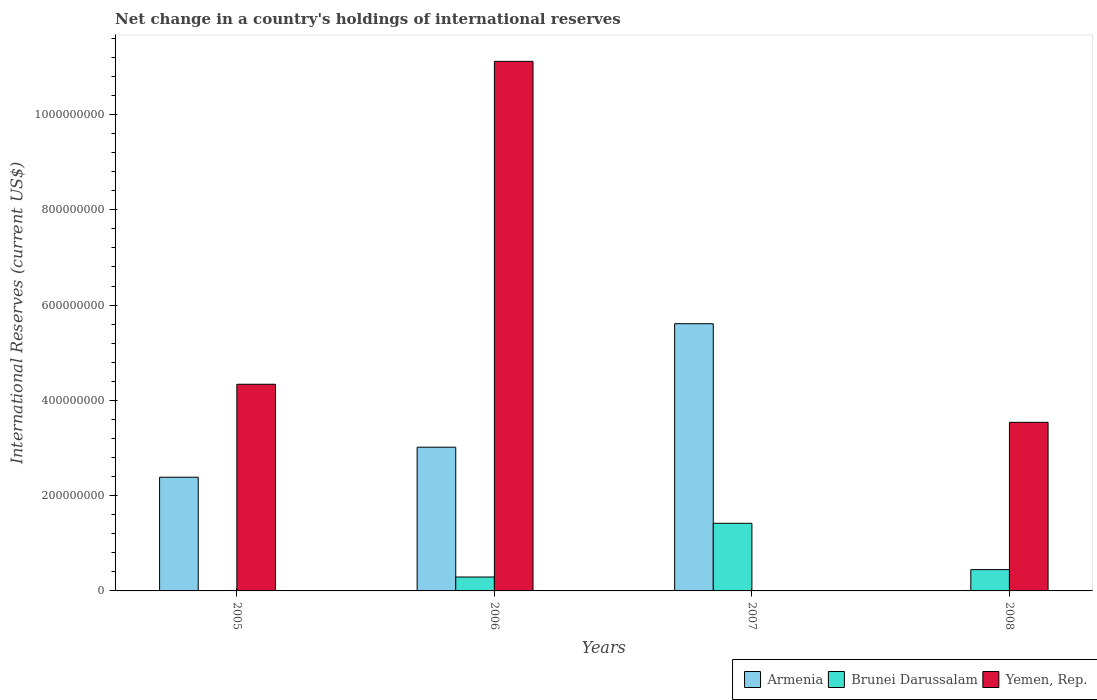How many different coloured bars are there?
Your answer should be very brief. 3. How many groups of bars are there?
Provide a succinct answer. 4. Are the number of bars per tick equal to the number of legend labels?
Keep it short and to the point. No. How many bars are there on the 2nd tick from the right?
Your answer should be compact. 2. What is the label of the 1st group of bars from the left?
Your response must be concise. 2005. In how many cases, is the number of bars for a given year not equal to the number of legend labels?
Ensure brevity in your answer.  3. Across all years, what is the maximum international reserves in Brunei Darussalam?
Provide a succinct answer. 1.42e+08. What is the total international reserves in Yemen, Rep. in the graph?
Keep it short and to the point. 1.90e+09. What is the difference between the international reserves in Armenia in 2005 and that in 2007?
Offer a very short reply. -3.22e+08. What is the difference between the international reserves in Brunei Darussalam in 2008 and the international reserves in Armenia in 2005?
Offer a very short reply. -1.94e+08. What is the average international reserves in Brunei Darussalam per year?
Your answer should be very brief. 5.40e+07. In the year 2006, what is the difference between the international reserves in Armenia and international reserves in Brunei Darussalam?
Provide a short and direct response. 2.72e+08. In how many years, is the international reserves in Armenia greater than 1000000000 US$?
Offer a terse response. 0. What is the ratio of the international reserves in Brunei Darussalam in 2007 to that in 2008?
Keep it short and to the point. 3.17. Is the international reserves in Armenia in 2005 less than that in 2007?
Your answer should be compact. Yes. Is the difference between the international reserves in Armenia in 2006 and 2007 greater than the difference between the international reserves in Brunei Darussalam in 2006 and 2007?
Ensure brevity in your answer.  No. What is the difference between the highest and the second highest international reserves in Brunei Darussalam?
Ensure brevity in your answer.  9.72e+07. What is the difference between the highest and the lowest international reserves in Yemen, Rep.?
Your response must be concise. 1.11e+09. In how many years, is the international reserves in Brunei Darussalam greater than the average international reserves in Brunei Darussalam taken over all years?
Make the answer very short. 1. Is the sum of the international reserves in Armenia in 2005 and 2006 greater than the maximum international reserves in Brunei Darussalam across all years?
Your answer should be compact. Yes. Is it the case that in every year, the sum of the international reserves in Armenia and international reserves in Yemen, Rep. is greater than the international reserves in Brunei Darussalam?
Offer a terse response. Yes. How many bars are there?
Provide a succinct answer. 9. How many years are there in the graph?
Your answer should be compact. 4. Are the values on the major ticks of Y-axis written in scientific E-notation?
Offer a very short reply. No. Does the graph contain any zero values?
Offer a terse response. Yes. Where does the legend appear in the graph?
Keep it short and to the point. Bottom right. What is the title of the graph?
Give a very brief answer. Net change in a country's holdings of international reserves. Does "Other small states" appear as one of the legend labels in the graph?
Your answer should be compact. No. What is the label or title of the Y-axis?
Your answer should be compact. International Reserves (current US$). What is the International Reserves (current US$) in Armenia in 2005?
Provide a succinct answer. 2.39e+08. What is the International Reserves (current US$) in Yemen, Rep. in 2005?
Your answer should be very brief. 4.34e+08. What is the International Reserves (current US$) of Armenia in 2006?
Your response must be concise. 3.02e+08. What is the International Reserves (current US$) of Brunei Darussalam in 2006?
Keep it short and to the point. 2.92e+07. What is the International Reserves (current US$) of Yemen, Rep. in 2006?
Provide a succinct answer. 1.11e+09. What is the International Reserves (current US$) of Armenia in 2007?
Offer a very short reply. 5.61e+08. What is the International Reserves (current US$) of Brunei Darussalam in 2007?
Give a very brief answer. 1.42e+08. What is the International Reserves (current US$) of Yemen, Rep. in 2007?
Give a very brief answer. 0. What is the International Reserves (current US$) in Armenia in 2008?
Provide a short and direct response. 0. What is the International Reserves (current US$) in Brunei Darussalam in 2008?
Offer a terse response. 4.47e+07. What is the International Reserves (current US$) in Yemen, Rep. in 2008?
Your answer should be compact. 3.54e+08. Across all years, what is the maximum International Reserves (current US$) in Armenia?
Ensure brevity in your answer.  5.61e+08. Across all years, what is the maximum International Reserves (current US$) of Brunei Darussalam?
Provide a short and direct response. 1.42e+08. Across all years, what is the maximum International Reserves (current US$) in Yemen, Rep.?
Your answer should be very brief. 1.11e+09. Across all years, what is the minimum International Reserves (current US$) in Armenia?
Offer a very short reply. 0. Across all years, what is the minimum International Reserves (current US$) in Brunei Darussalam?
Provide a succinct answer. 0. What is the total International Reserves (current US$) of Armenia in the graph?
Provide a succinct answer. 1.10e+09. What is the total International Reserves (current US$) of Brunei Darussalam in the graph?
Your answer should be very brief. 2.16e+08. What is the total International Reserves (current US$) in Yemen, Rep. in the graph?
Make the answer very short. 1.90e+09. What is the difference between the International Reserves (current US$) of Armenia in 2005 and that in 2006?
Offer a very short reply. -6.30e+07. What is the difference between the International Reserves (current US$) in Yemen, Rep. in 2005 and that in 2006?
Ensure brevity in your answer.  -6.78e+08. What is the difference between the International Reserves (current US$) in Armenia in 2005 and that in 2007?
Give a very brief answer. -3.22e+08. What is the difference between the International Reserves (current US$) of Yemen, Rep. in 2005 and that in 2008?
Your answer should be very brief. 7.99e+07. What is the difference between the International Reserves (current US$) of Armenia in 2006 and that in 2007?
Offer a very short reply. -2.59e+08. What is the difference between the International Reserves (current US$) of Brunei Darussalam in 2006 and that in 2007?
Your response must be concise. -1.13e+08. What is the difference between the International Reserves (current US$) in Brunei Darussalam in 2006 and that in 2008?
Your answer should be very brief. -1.55e+07. What is the difference between the International Reserves (current US$) in Yemen, Rep. in 2006 and that in 2008?
Offer a very short reply. 7.58e+08. What is the difference between the International Reserves (current US$) in Brunei Darussalam in 2007 and that in 2008?
Offer a very short reply. 9.72e+07. What is the difference between the International Reserves (current US$) in Armenia in 2005 and the International Reserves (current US$) in Brunei Darussalam in 2006?
Give a very brief answer. 2.09e+08. What is the difference between the International Reserves (current US$) of Armenia in 2005 and the International Reserves (current US$) of Yemen, Rep. in 2006?
Your answer should be compact. -8.73e+08. What is the difference between the International Reserves (current US$) in Armenia in 2005 and the International Reserves (current US$) in Brunei Darussalam in 2007?
Offer a very short reply. 9.67e+07. What is the difference between the International Reserves (current US$) in Armenia in 2005 and the International Reserves (current US$) in Brunei Darussalam in 2008?
Your response must be concise. 1.94e+08. What is the difference between the International Reserves (current US$) in Armenia in 2005 and the International Reserves (current US$) in Yemen, Rep. in 2008?
Offer a very short reply. -1.15e+08. What is the difference between the International Reserves (current US$) of Armenia in 2006 and the International Reserves (current US$) of Brunei Darussalam in 2007?
Your answer should be compact. 1.60e+08. What is the difference between the International Reserves (current US$) in Armenia in 2006 and the International Reserves (current US$) in Brunei Darussalam in 2008?
Offer a very short reply. 2.57e+08. What is the difference between the International Reserves (current US$) in Armenia in 2006 and the International Reserves (current US$) in Yemen, Rep. in 2008?
Provide a short and direct response. -5.22e+07. What is the difference between the International Reserves (current US$) of Brunei Darussalam in 2006 and the International Reserves (current US$) of Yemen, Rep. in 2008?
Your answer should be compact. -3.25e+08. What is the difference between the International Reserves (current US$) of Armenia in 2007 and the International Reserves (current US$) of Brunei Darussalam in 2008?
Your answer should be compact. 5.16e+08. What is the difference between the International Reserves (current US$) in Armenia in 2007 and the International Reserves (current US$) in Yemen, Rep. in 2008?
Provide a short and direct response. 2.07e+08. What is the difference between the International Reserves (current US$) of Brunei Darussalam in 2007 and the International Reserves (current US$) of Yemen, Rep. in 2008?
Ensure brevity in your answer.  -2.12e+08. What is the average International Reserves (current US$) in Armenia per year?
Make the answer very short. 2.75e+08. What is the average International Reserves (current US$) in Brunei Darussalam per year?
Your response must be concise. 5.40e+07. What is the average International Reserves (current US$) in Yemen, Rep. per year?
Your answer should be compact. 4.75e+08. In the year 2005, what is the difference between the International Reserves (current US$) of Armenia and International Reserves (current US$) of Yemen, Rep.?
Give a very brief answer. -1.95e+08. In the year 2006, what is the difference between the International Reserves (current US$) in Armenia and International Reserves (current US$) in Brunei Darussalam?
Offer a very short reply. 2.72e+08. In the year 2006, what is the difference between the International Reserves (current US$) in Armenia and International Reserves (current US$) in Yemen, Rep.?
Provide a short and direct response. -8.10e+08. In the year 2006, what is the difference between the International Reserves (current US$) in Brunei Darussalam and International Reserves (current US$) in Yemen, Rep.?
Provide a short and direct response. -1.08e+09. In the year 2007, what is the difference between the International Reserves (current US$) in Armenia and International Reserves (current US$) in Brunei Darussalam?
Offer a very short reply. 4.19e+08. In the year 2008, what is the difference between the International Reserves (current US$) in Brunei Darussalam and International Reserves (current US$) in Yemen, Rep.?
Keep it short and to the point. -3.09e+08. What is the ratio of the International Reserves (current US$) in Armenia in 2005 to that in 2006?
Your response must be concise. 0.79. What is the ratio of the International Reserves (current US$) in Yemen, Rep. in 2005 to that in 2006?
Your answer should be compact. 0.39. What is the ratio of the International Reserves (current US$) of Armenia in 2005 to that in 2007?
Provide a short and direct response. 0.43. What is the ratio of the International Reserves (current US$) of Yemen, Rep. in 2005 to that in 2008?
Your answer should be compact. 1.23. What is the ratio of the International Reserves (current US$) in Armenia in 2006 to that in 2007?
Your answer should be very brief. 0.54. What is the ratio of the International Reserves (current US$) of Brunei Darussalam in 2006 to that in 2007?
Provide a succinct answer. 0.21. What is the ratio of the International Reserves (current US$) of Brunei Darussalam in 2006 to that in 2008?
Offer a very short reply. 0.65. What is the ratio of the International Reserves (current US$) in Yemen, Rep. in 2006 to that in 2008?
Offer a very short reply. 3.14. What is the ratio of the International Reserves (current US$) in Brunei Darussalam in 2007 to that in 2008?
Your answer should be very brief. 3.17. What is the difference between the highest and the second highest International Reserves (current US$) in Armenia?
Provide a succinct answer. 2.59e+08. What is the difference between the highest and the second highest International Reserves (current US$) of Brunei Darussalam?
Your answer should be very brief. 9.72e+07. What is the difference between the highest and the second highest International Reserves (current US$) in Yemen, Rep.?
Offer a very short reply. 6.78e+08. What is the difference between the highest and the lowest International Reserves (current US$) of Armenia?
Keep it short and to the point. 5.61e+08. What is the difference between the highest and the lowest International Reserves (current US$) of Brunei Darussalam?
Your answer should be very brief. 1.42e+08. What is the difference between the highest and the lowest International Reserves (current US$) of Yemen, Rep.?
Ensure brevity in your answer.  1.11e+09. 